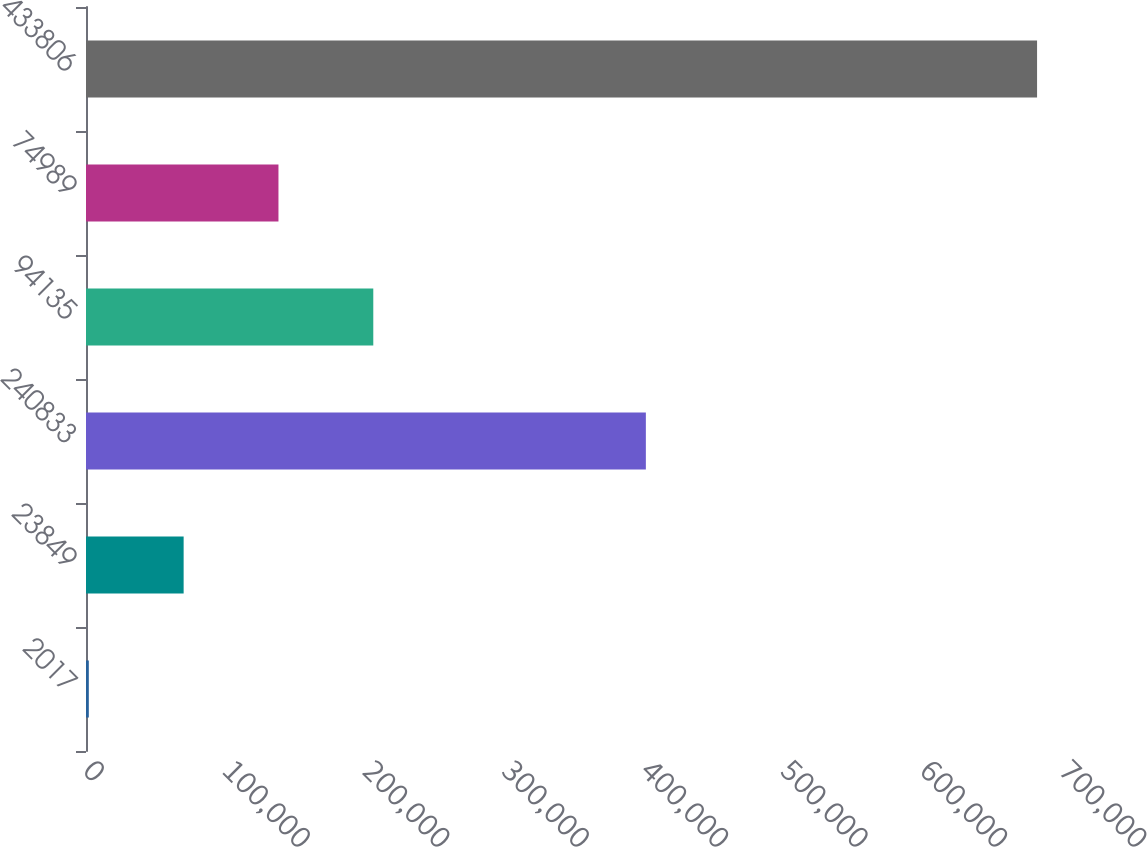<chart> <loc_0><loc_0><loc_500><loc_500><bar_chart><fcel>2017<fcel>23849<fcel>240833<fcel>94135<fcel>74989<fcel>433806<nl><fcel>2015<fcel>70025.3<fcel>401537<fcel>206046<fcel>138036<fcel>682118<nl></chart> 